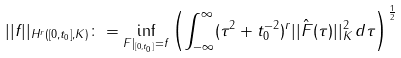Convert formula to latex. <formula><loc_0><loc_0><loc_500><loc_500>| | f | | _ { H ^ { r } ( [ 0 , t _ { 0 } ] , K ) } \colon = \inf _ { F | _ { [ 0 , t _ { 0 } ] } = f } \left ( \int _ { - \infty } ^ { \infty } ( \tau ^ { 2 } + t _ { 0 } ^ { - 2 } ) ^ { r } | | \hat { F } ( \tau ) | | _ { K } ^ { 2 } \, d \tau \right ) ^ { \frac { 1 } { 2 } }</formula> 